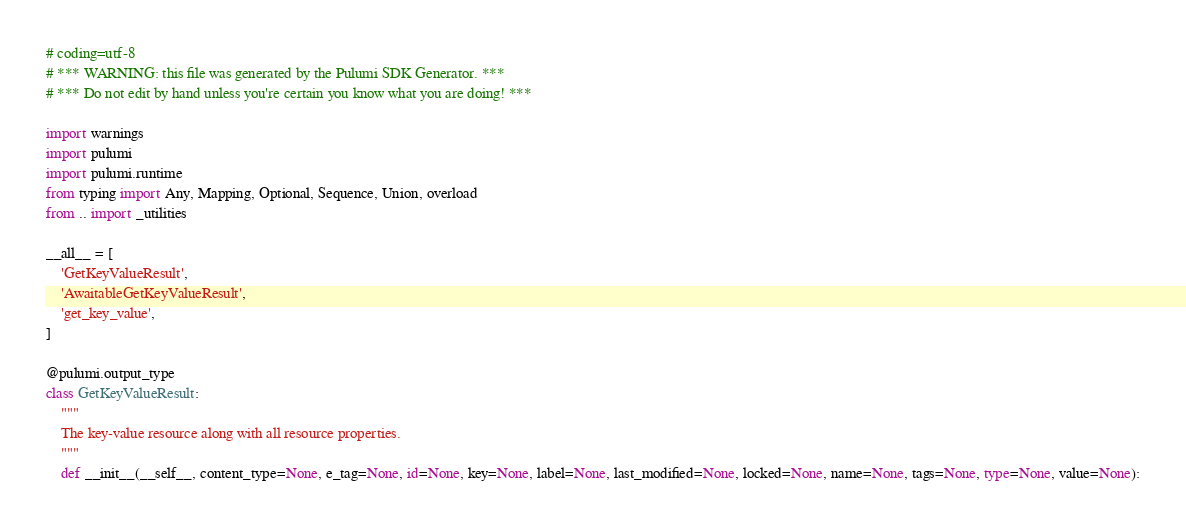<code> <loc_0><loc_0><loc_500><loc_500><_Python_># coding=utf-8
# *** WARNING: this file was generated by the Pulumi SDK Generator. ***
# *** Do not edit by hand unless you're certain you know what you are doing! ***

import warnings
import pulumi
import pulumi.runtime
from typing import Any, Mapping, Optional, Sequence, Union, overload
from .. import _utilities

__all__ = [
    'GetKeyValueResult',
    'AwaitableGetKeyValueResult',
    'get_key_value',
]

@pulumi.output_type
class GetKeyValueResult:
    """
    The key-value resource along with all resource properties.
    """
    def __init__(__self__, content_type=None, e_tag=None, id=None, key=None, label=None, last_modified=None, locked=None, name=None, tags=None, type=None, value=None):</code> 